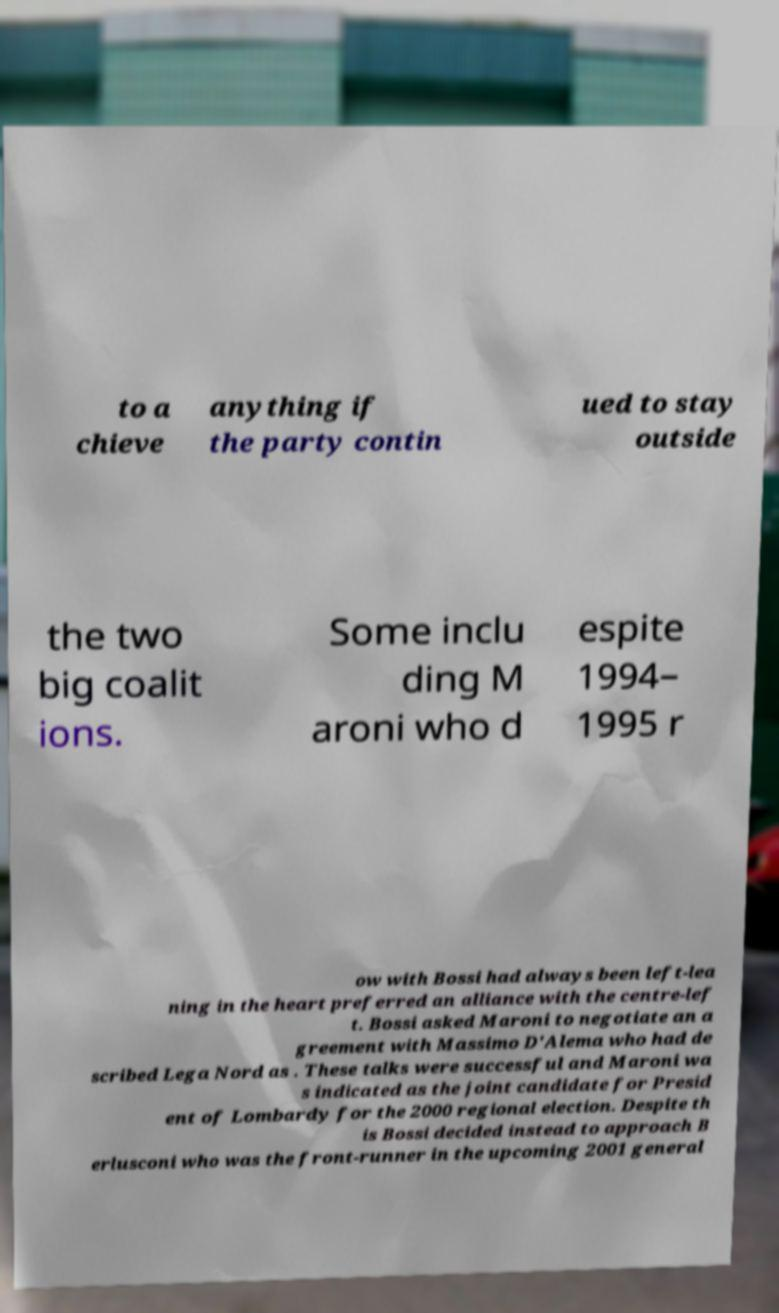There's text embedded in this image that I need extracted. Can you transcribe it verbatim? to a chieve anything if the party contin ued to stay outside the two big coalit ions. Some inclu ding M aroni who d espite 1994– 1995 r ow with Bossi had always been left-lea ning in the heart preferred an alliance with the centre-lef t. Bossi asked Maroni to negotiate an a greement with Massimo D'Alema who had de scribed Lega Nord as . These talks were successful and Maroni wa s indicated as the joint candidate for Presid ent of Lombardy for the 2000 regional election. Despite th is Bossi decided instead to approach B erlusconi who was the front-runner in the upcoming 2001 general 